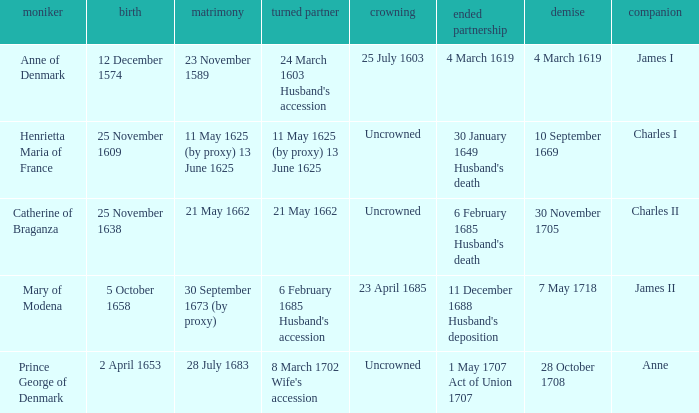On what date did James II take a consort? 6 February 1685 Husband's accession. 